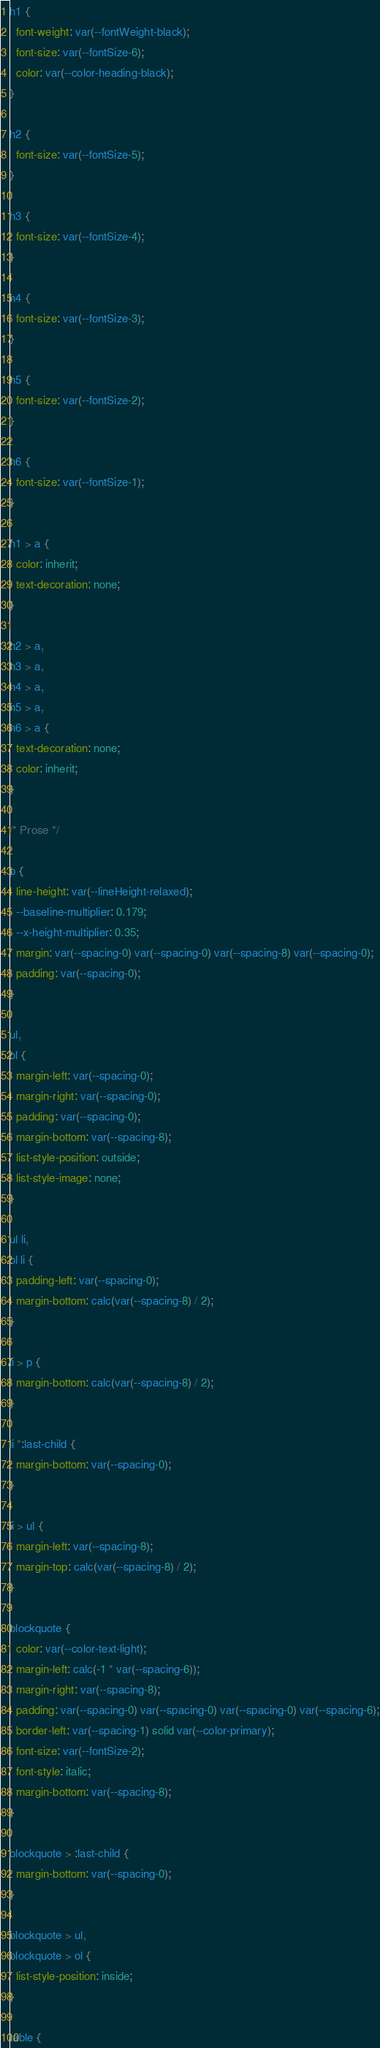<code> <loc_0><loc_0><loc_500><loc_500><_CSS_>
h1 {
  font-weight: var(--fontWeight-black);
  font-size: var(--fontSize-6);
  color: var(--color-heading-black);
}

h2 {
  font-size: var(--fontSize-5);
}

h3 {
  font-size: var(--fontSize-4);
}

h4 {
  font-size: var(--fontSize-3);
}

h5 {
  font-size: var(--fontSize-2);
}

h6 {
  font-size: var(--fontSize-1);
}

h1 > a {
  color: inherit;
  text-decoration: none;
}

h2 > a,
h3 > a,
h4 > a,
h5 > a,
h6 > a {
  text-decoration: none;
  color: inherit;
}

/* Prose */

p {
  line-height: var(--lineHeight-relaxed);
  --baseline-multiplier: 0.179;
  --x-height-multiplier: 0.35;
  margin: var(--spacing-0) var(--spacing-0) var(--spacing-8) var(--spacing-0);
  padding: var(--spacing-0);
}

ul,
ol {
  margin-left: var(--spacing-0);
  margin-right: var(--spacing-0);
  padding: var(--spacing-0);
  margin-bottom: var(--spacing-8);
  list-style-position: outside;
  list-style-image: none;
}

ul li,
ol li {
  padding-left: var(--spacing-0);
  margin-bottom: calc(var(--spacing-8) / 2);
}

li > p {
  margin-bottom: calc(var(--spacing-8) / 2);
}

li *:last-child {
  margin-bottom: var(--spacing-0);
}

li > ul {
  margin-left: var(--spacing-8);
  margin-top: calc(var(--spacing-8) / 2);
}

blockquote {
  color: var(--color-text-light);
  margin-left: calc(-1 * var(--spacing-6));
  margin-right: var(--spacing-8);
  padding: var(--spacing-0) var(--spacing-0) var(--spacing-0) var(--spacing-6);
  border-left: var(--spacing-1) solid var(--color-primary);
  font-size: var(--fontSize-2);
  font-style: italic;
  margin-bottom: var(--spacing-8);
}

blockquote > :last-child {
  margin-bottom: var(--spacing-0);
}

blockquote > ul,
blockquote > ol {
  list-style-position: inside;
}

table {</code> 